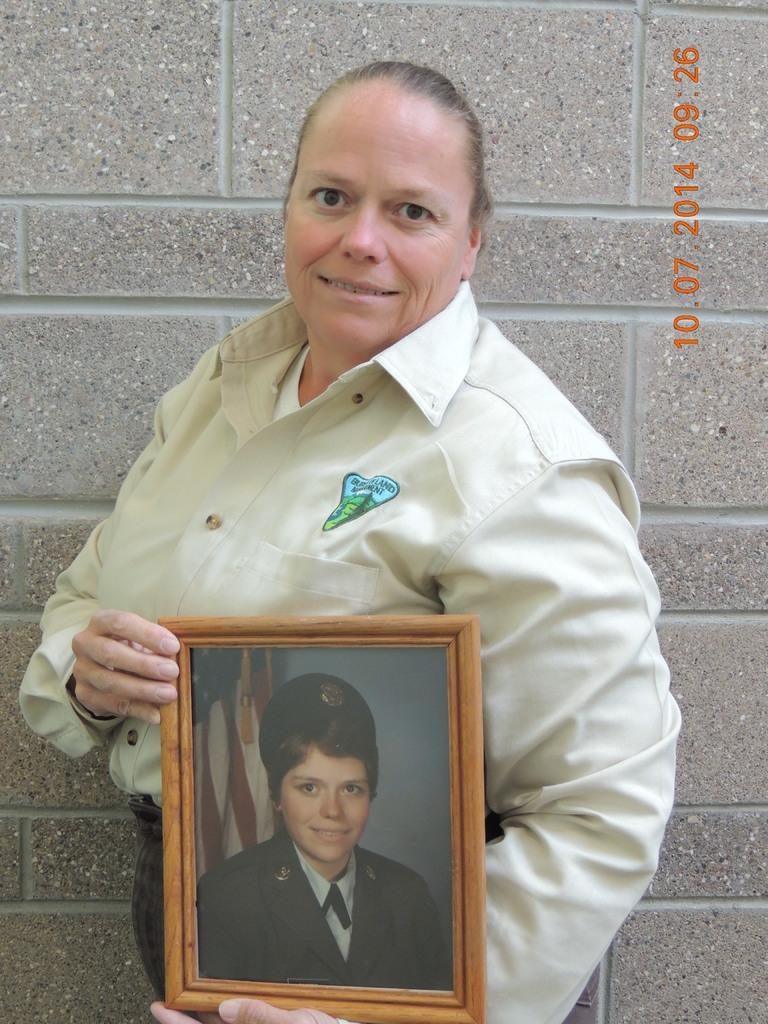What is the main subject of the image? The main subject of the image is a woman. Can you describe the woman's appearance or attire? The woman is in uniform and is smiling. What is the woman doing in the image? The woman is standing and holding a photo frame. What can be seen in the background of the image? There is a wall in the background of the image. Is there any additional information about the image itself? Yes, there is a watermark in the top right corner of the image. What type of discussion is taking place near the mailbox in the image? There is no mailbox present in the image, and therefore no discussion can be observed. Can you describe the contents of the drawer in the image? There is no drawer present in the image. 